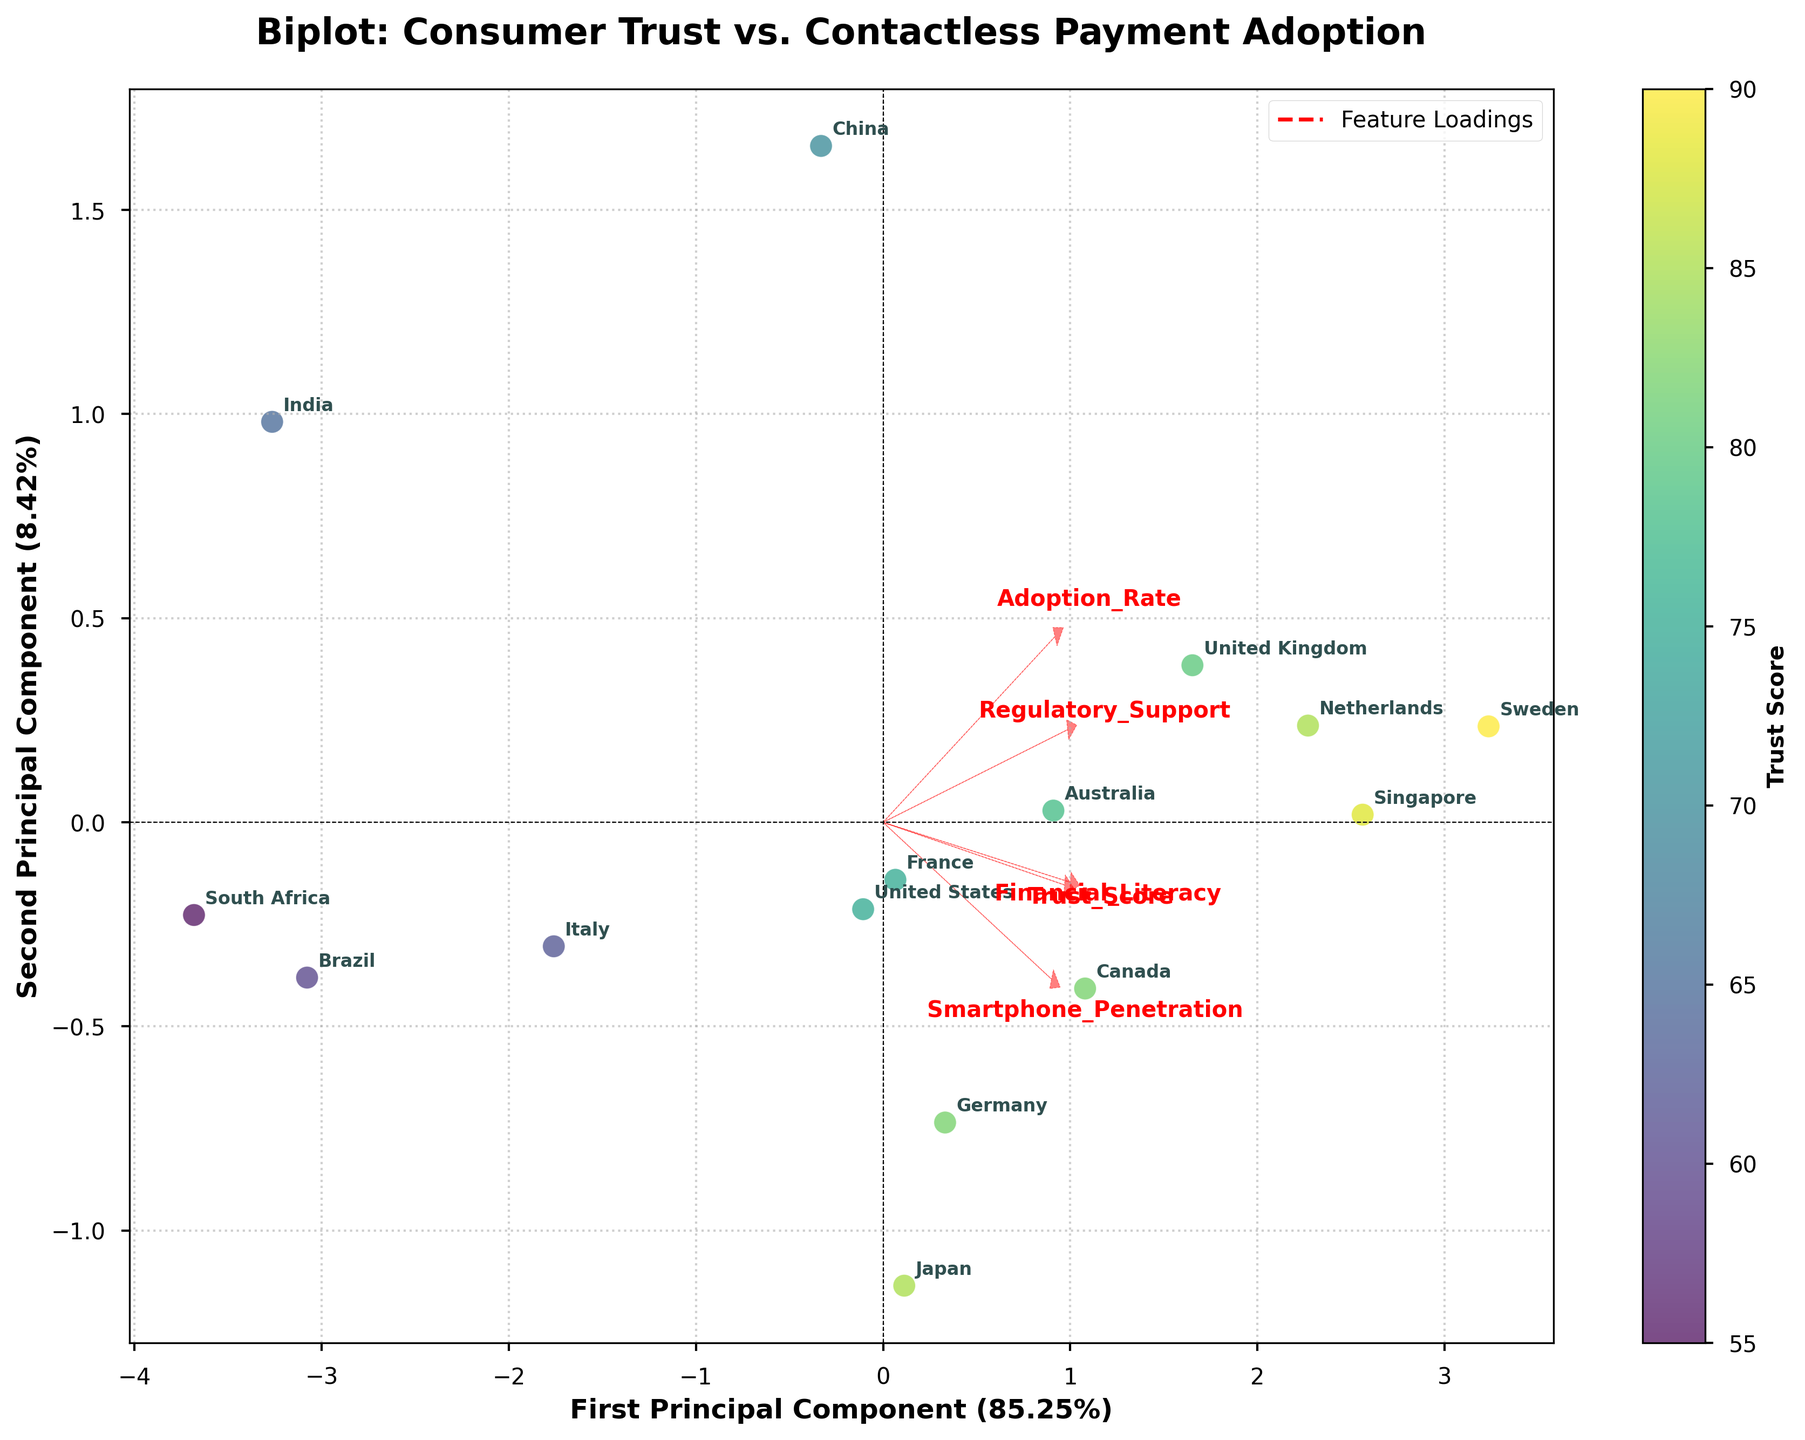What is the title of the plot? The title of the plot is displayed at the top center of the figure.
Answer: Biplot: Consumer Trust vs. Contactless Payment Adoption How many principal components are displayed in the biplot? The figure displays two principal components, denoted by the x-axis and y-axis labels.
Answer: Two Which country has the highest Trust Score according to the color scale? The color scale (viridis colormap) indicates that Sweden, with the darkest shade, has the highest Trust Score.
Answer: Sweden What does the x-axis represent in the biplot? The x-axis represents the First Principal Component, as labeled on the plot.
Answer: First Principal Component Which feature vector has the highest loading on the second principal component? By examining the red dashed arrows, Financial Literacy shows the highest projection on the second principal component.
Answer: Financial Literacy How are the countries with high Adoption Rates positioned on the biplot? Countries with high Adoption Rates, like Sweden and China, are positioned toward the right side of the biplot.
Answer: Right side Is trust in financial institutions positively correlated with the willingness to adopt contactless payment systems? To determine correlation, observe the direction of the arrows for Trust_Score and Adoption_Rate. Both point towards the right, indicating a positive correlation.
Answer: Yes Which country appears closest to the origin in the biplot? The origin is the point (0, 0). South Africa appears closest to the origin among the countries listed.
Answer: South Africa Compare the Regulatory Support in the United Kingdom and Japan based on the loading vectors. The position of the Regulatory_Support vector can be paired with the positions of the UK and Japan. The UK is further along the Regulatory_Support vector compared to Japan, indicating higher regulatory support.
Answer: United Kingdom What is the proportion of variance explained by the first principal component? The x-axis label indicates the percentage of variance explained. It shows 47.8%.
Answer: 47.8% 